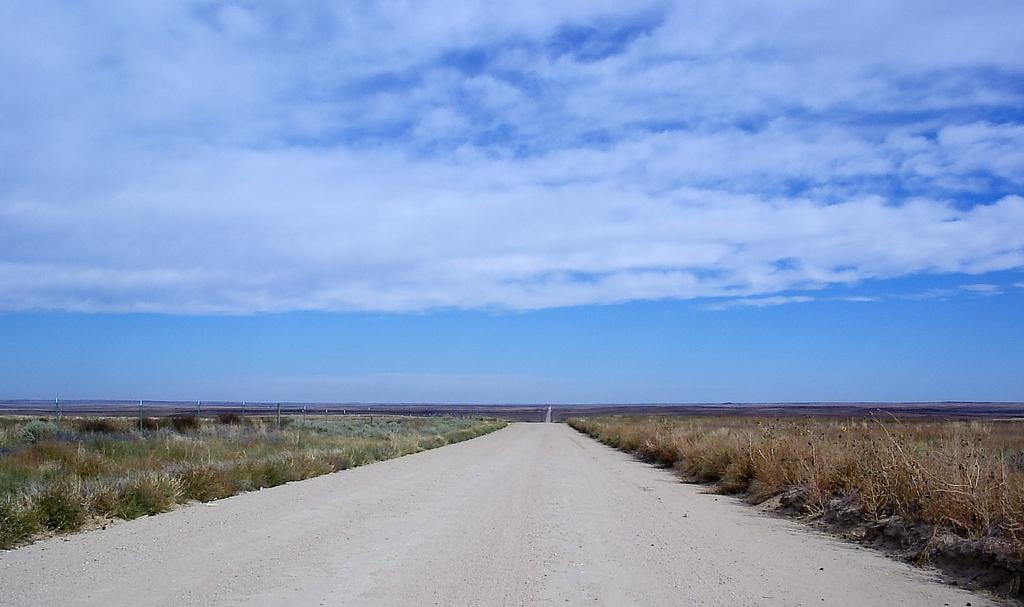What is located at the bottom of the image? There is a road at the bottom of the image. What type of vegetation can be seen on both sides of the road? There is grass on both sides of the road. What is visible at the top of the image? The sky is visible at the top of the image. What is the color of the sky in the image? The sky is blue in the image. What else can be seen in the sky? Clouds are present in the sky. What type of bird is writing in a notebook with glue in the image? There is no bird, notebook, or glue present in the image. 